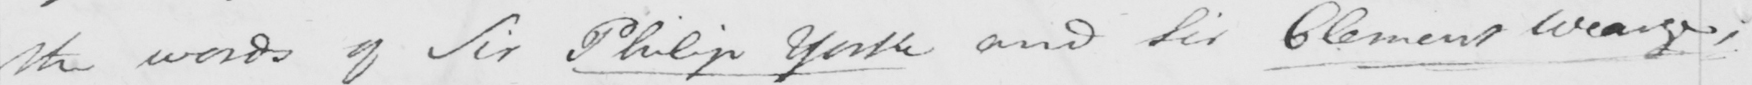Can you tell me what this handwritten text says? the words of Sir Philip Yorke and Sir Clement Wearge , 